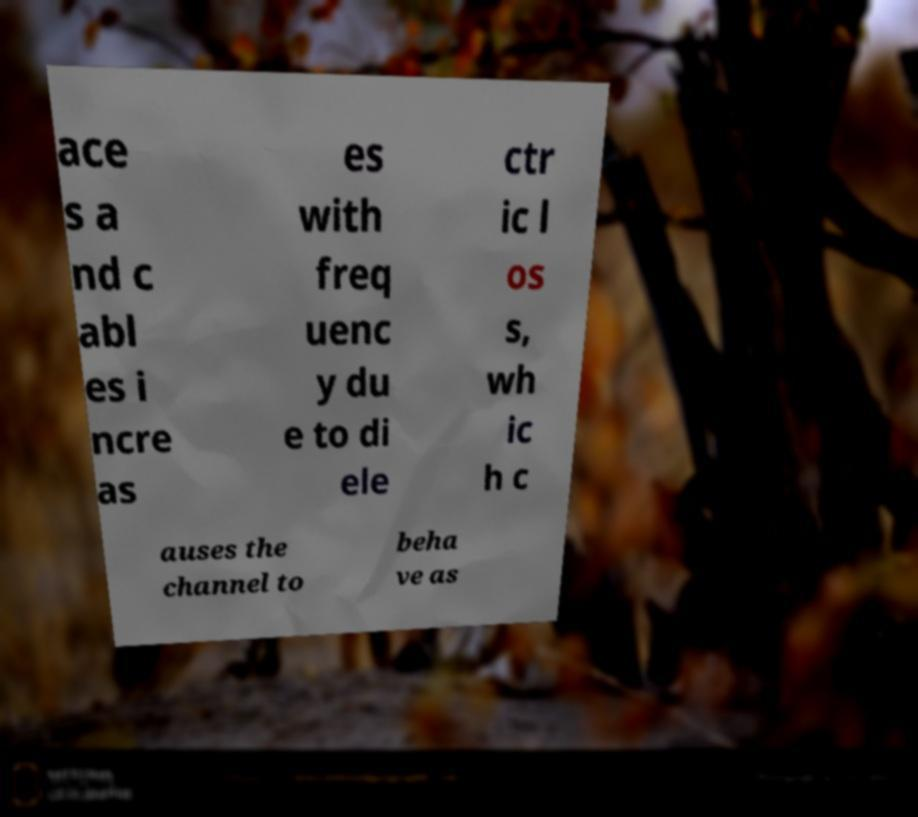For documentation purposes, I need the text within this image transcribed. Could you provide that? ace s a nd c abl es i ncre as es with freq uenc y du e to di ele ctr ic l os s, wh ic h c auses the channel to beha ve as 